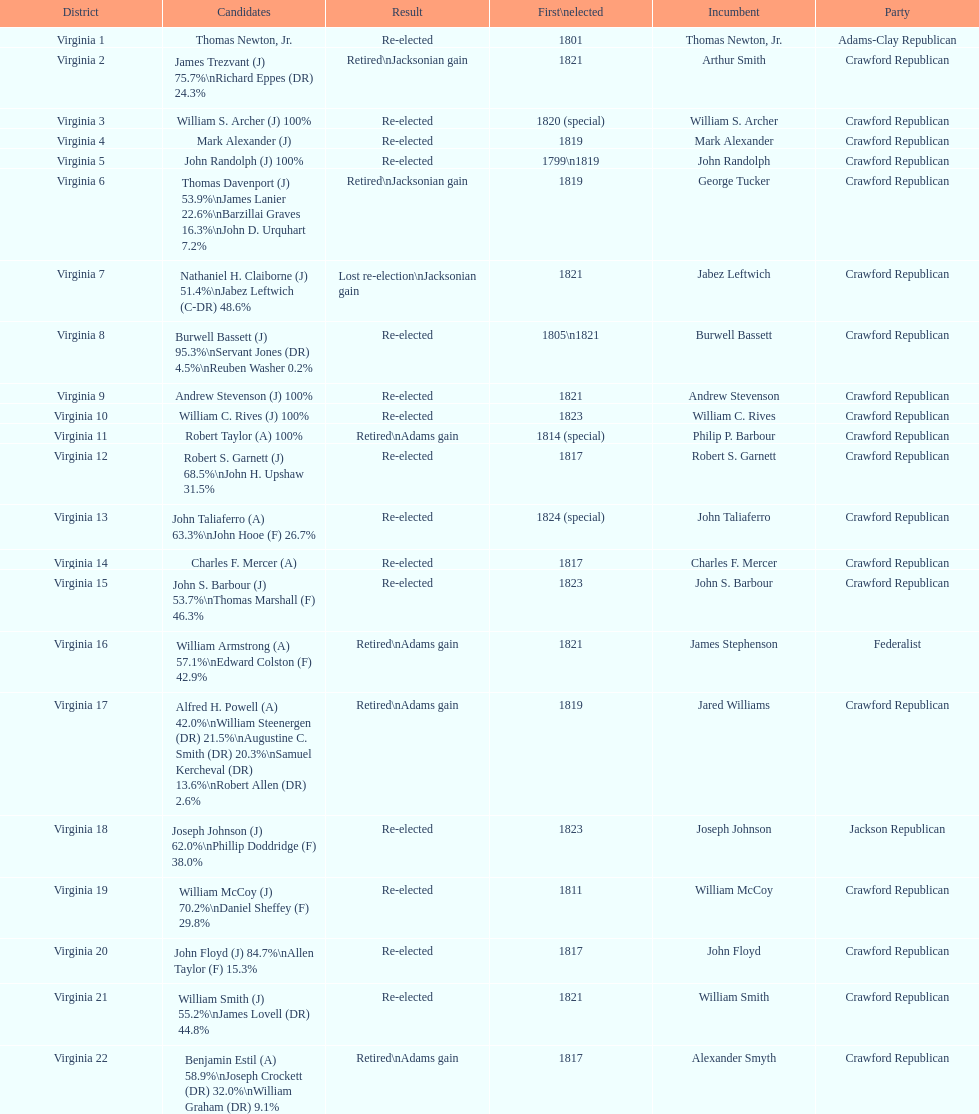How many candidates were there for virginia 17 district? 5. 